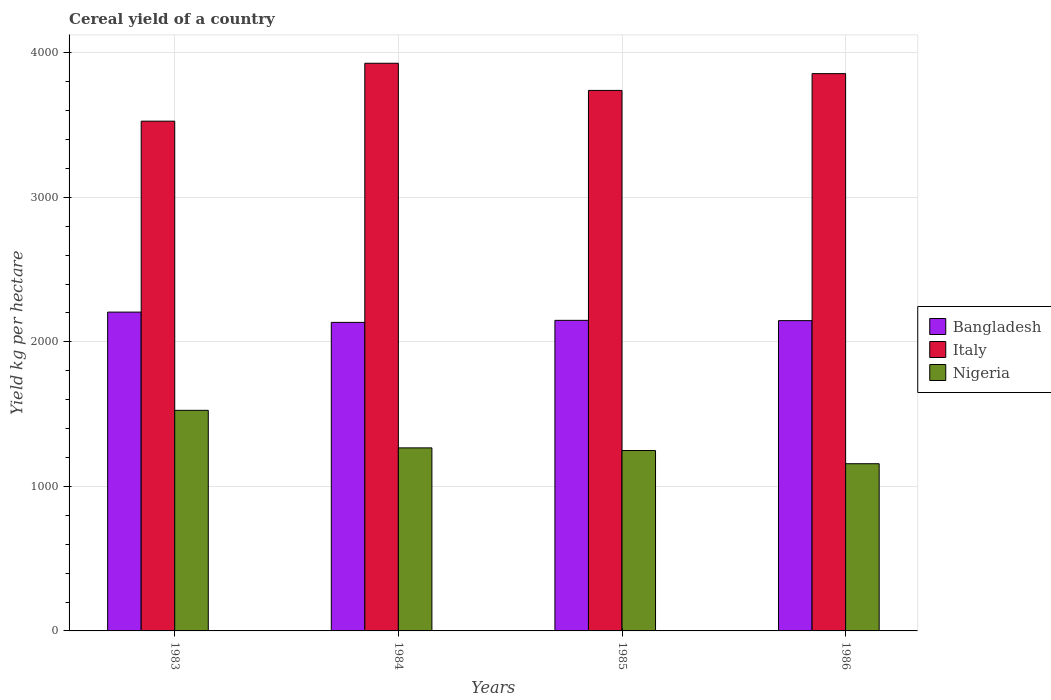How many groups of bars are there?
Give a very brief answer. 4. Are the number of bars per tick equal to the number of legend labels?
Your answer should be very brief. Yes. How many bars are there on the 4th tick from the left?
Offer a terse response. 3. What is the total cereal yield in Nigeria in 1983?
Offer a very short reply. 1526.02. Across all years, what is the maximum total cereal yield in Bangladesh?
Make the answer very short. 2205.6. Across all years, what is the minimum total cereal yield in Nigeria?
Your answer should be very brief. 1156.71. In which year was the total cereal yield in Bangladesh minimum?
Offer a very short reply. 1984. What is the total total cereal yield in Bangladesh in the graph?
Provide a succinct answer. 8635.34. What is the difference between the total cereal yield in Nigeria in 1983 and that in 1984?
Your answer should be very brief. 259.68. What is the difference between the total cereal yield in Bangladesh in 1986 and the total cereal yield in Nigeria in 1983?
Give a very brief answer. 620.63. What is the average total cereal yield in Bangladesh per year?
Your answer should be very brief. 2158.84. In the year 1984, what is the difference between the total cereal yield in Nigeria and total cereal yield in Bangladesh?
Ensure brevity in your answer.  -868.22. In how many years, is the total cereal yield in Italy greater than 2000 kg per hectare?
Make the answer very short. 4. What is the ratio of the total cereal yield in Bangladesh in 1983 to that in 1986?
Give a very brief answer. 1.03. Is the difference between the total cereal yield in Nigeria in 1985 and 1986 greater than the difference between the total cereal yield in Bangladesh in 1985 and 1986?
Keep it short and to the point. Yes. What is the difference between the highest and the second highest total cereal yield in Nigeria?
Keep it short and to the point. 259.68. What is the difference between the highest and the lowest total cereal yield in Bangladesh?
Provide a short and direct response. 71.04. In how many years, is the total cereal yield in Bangladesh greater than the average total cereal yield in Bangladesh taken over all years?
Make the answer very short. 1. What does the 2nd bar from the left in 1984 represents?
Provide a short and direct response. Italy. Are all the bars in the graph horizontal?
Give a very brief answer. No. How many years are there in the graph?
Offer a terse response. 4. What is the difference between two consecutive major ticks on the Y-axis?
Offer a terse response. 1000. Does the graph contain grids?
Offer a terse response. Yes. Where does the legend appear in the graph?
Your answer should be very brief. Center right. What is the title of the graph?
Give a very brief answer. Cereal yield of a country. What is the label or title of the X-axis?
Provide a short and direct response. Years. What is the label or title of the Y-axis?
Your answer should be very brief. Yield kg per hectare. What is the Yield kg per hectare in Bangladesh in 1983?
Offer a terse response. 2205.6. What is the Yield kg per hectare in Italy in 1983?
Keep it short and to the point. 3526.6. What is the Yield kg per hectare of Nigeria in 1983?
Ensure brevity in your answer.  1526.02. What is the Yield kg per hectare of Bangladesh in 1984?
Provide a short and direct response. 2134.56. What is the Yield kg per hectare of Italy in 1984?
Offer a terse response. 3927.2. What is the Yield kg per hectare in Nigeria in 1984?
Offer a terse response. 1266.34. What is the Yield kg per hectare in Bangladesh in 1985?
Provide a short and direct response. 2148.54. What is the Yield kg per hectare of Italy in 1985?
Your response must be concise. 3739.32. What is the Yield kg per hectare of Nigeria in 1985?
Make the answer very short. 1247.93. What is the Yield kg per hectare of Bangladesh in 1986?
Give a very brief answer. 2146.64. What is the Yield kg per hectare of Italy in 1986?
Offer a very short reply. 3855.44. What is the Yield kg per hectare in Nigeria in 1986?
Make the answer very short. 1156.71. Across all years, what is the maximum Yield kg per hectare of Bangladesh?
Keep it short and to the point. 2205.6. Across all years, what is the maximum Yield kg per hectare in Italy?
Your answer should be compact. 3927.2. Across all years, what is the maximum Yield kg per hectare of Nigeria?
Your response must be concise. 1526.02. Across all years, what is the minimum Yield kg per hectare of Bangladesh?
Provide a short and direct response. 2134.56. Across all years, what is the minimum Yield kg per hectare in Italy?
Offer a very short reply. 3526.6. Across all years, what is the minimum Yield kg per hectare in Nigeria?
Offer a very short reply. 1156.71. What is the total Yield kg per hectare in Bangladesh in the graph?
Provide a succinct answer. 8635.34. What is the total Yield kg per hectare of Italy in the graph?
Give a very brief answer. 1.50e+04. What is the total Yield kg per hectare of Nigeria in the graph?
Provide a succinct answer. 5196.99. What is the difference between the Yield kg per hectare in Bangladesh in 1983 and that in 1984?
Make the answer very short. 71.04. What is the difference between the Yield kg per hectare of Italy in 1983 and that in 1984?
Your response must be concise. -400.6. What is the difference between the Yield kg per hectare in Nigeria in 1983 and that in 1984?
Your answer should be very brief. 259.68. What is the difference between the Yield kg per hectare in Bangladesh in 1983 and that in 1985?
Provide a succinct answer. 57.06. What is the difference between the Yield kg per hectare of Italy in 1983 and that in 1985?
Offer a very short reply. -212.72. What is the difference between the Yield kg per hectare in Nigeria in 1983 and that in 1985?
Offer a very short reply. 278.09. What is the difference between the Yield kg per hectare of Bangladesh in 1983 and that in 1986?
Offer a terse response. 58.96. What is the difference between the Yield kg per hectare of Italy in 1983 and that in 1986?
Your answer should be compact. -328.84. What is the difference between the Yield kg per hectare in Nigeria in 1983 and that in 1986?
Offer a terse response. 369.3. What is the difference between the Yield kg per hectare in Bangladesh in 1984 and that in 1985?
Make the answer very short. -13.98. What is the difference between the Yield kg per hectare of Italy in 1984 and that in 1985?
Your answer should be very brief. 187.88. What is the difference between the Yield kg per hectare in Nigeria in 1984 and that in 1985?
Provide a succinct answer. 18.41. What is the difference between the Yield kg per hectare of Bangladesh in 1984 and that in 1986?
Your answer should be compact. -12.08. What is the difference between the Yield kg per hectare of Italy in 1984 and that in 1986?
Provide a succinct answer. 71.76. What is the difference between the Yield kg per hectare of Nigeria in 1984 and that in 1986?
Offer a very short reply. 109.62. What is the difference between the Yield kg per hectare of Bangladesh in 1985 and that in 1986?
Offer a terse response. 1.9. What is the difference between the Yield kg per hectare of Italy in 1985 and that in 1986?
Offer a very short reply. -116.12. What is the difference between the Yield kg per hectare of Nigeria in 1985 and that in 1986?
Your response must be concise. 91.22. What is the difference between the Yield kg per hectare of Bangladesh in 1983 and the Yield kg per hectare of Italy in 1984?
Make the answer very short. -1721.6. What is the difference between the Yield kg per hectare in Bangladesh in 1983 and the Yield kg per hectare in Nigeria in 1984?
Offer a very short reply. 939.26. What is the difference between the Yield kg per hectare of Italy in 1983 and the Yield kg per hectare of Nigeria in 1984?
Provide a short and direct response. 2260.26. What is the difference between the Yield kg per hectare in Bangladesh in 1983 and the Yield kg per hectare in Italy in 1985?
Offer a terse response. -1533.71. What is the difference between the Yield kg per hectare of Bangladesh in 1983 and the Yield kg per hectare of Nigeria in 1985?
Ensure brevity in your answer.  957.67. What is the difference between the Yield kg per hectare in Italy in 1983 and the Yield kg per hectare in Nigeria in 1985?
Provide a succinct answer. 2278.67. What is the difference between the Yield kg per hectare of Bangladesh in 1983 and the Yield kg per hectare of Italy in 1986?
Your answer should be very brief. -1649.84. What is the difference between the Yield kg per hectare of Bangladesh in 1983 and the Yield kg per hectare of Nigeria in 1986?
Make the answer very short. 1048.89. What is the difference between the Yield kg per hectare in Italy in 1983 and the Yield kg per hectare in Nigeria in 1986?
Provide a short and direct response. 2369.89. What is the difference between the Yield kg per hectare in Bangladesh in 1984 and the Yield kg per hectare in Italy in 1985?
Offer a very short reply. -1604.76. What is the difference between the Yield kg per hectare of Bangladesh in 1984 and the Yield kg per hectare of Nigeria in 1985?
Your answer should be very brief. 886.63. What is the difference between the Yield kg per hectare of Italy in 1984 and the Yield kg per hectare of Nigeria in 1985?
Offer a very short reply. 2679.27. What is the difference between the Yield kg per hectare in Bangladesh in 1984 and the Yield kg per hectare in Italy in 1986?
Offer a very short reply. -1720.88. What is the difference between the Yield kg per hectare in Bangladesh in 1984 and the Yield kg per hectare in Nigeria in 1986?
Offer a very short reply. 977.85. What is the difference between the Yield kg per hectare of Italy in 1984 and the Yield kg per hectare of Nigeria in 1986?
Offer a terse response. 2770.48. What is the difference between the Yield kg per hectare of Bangladesh in 1985 and the Yield kg per hectare of Italy in 1986?
Give a very brief answer. -1706.89. What is the difference between the Yield kg per hectare of Bangladesh in 1985 and the Yield kg per hectare of Nigeria in 1986?
Ensure brevity in your answer.  991.83. What is the difference between the Yield kg per hectare of Italy in 1985 and the Yield kg per hectare of Nigeria in 1986?
Your answer should be very brief. 2582.6. What is the average Yield kg per hectare in Bangladesh per year?
Keep it short and to the point. 2158.84. What is the average Yield kg per hectare of Italy per year?
Make the answer very short. 3762.14. What is the average Yield kg per hectare in Nigeria per year?
Give a very brief answer. 1299.25. In the year 1983, what is the difference between the Yield kg per hectare in Bangladesh and Yield kg per hectare in Italy?
Give a very brief answer. -1321. In the year 1983, what is the difference between the Yield kg per hectare of Bangladesh and Yield kg per hectare of Nigeria?
Ensure brevity in your answer.  679.58. In the year 1983, what is the difference between the Yield kg per hectare of Italy and Yield kg per hectare of Nigeria?
Provide a short and direct response. 2000.58. In the year 1984, what is the difference between the Yield kg per hectare of Bangladesh and Yield kg per hectare of Italy?
Provide a succinct answer. -1792.64. In the year 1984, what is the difference between the Yield kg per hectare in Bangladesh and Yield kg per hectare in Nigeria?
Your answer should be very brief. 868.22. In the year 1984, what is the difference between the Yield kg per hectare of Italy and Yield kg per hectare of Nigeria?
Make the answer very short. 2660.86. In the year 1985, what is the difference between the Yield kg per hectare in Bangladesh and Yield kg per hectare in Italy?
Make the answer very short. -1590.77. In the year 1985, what is the difference between the Yield kg per hectare of Bangladesh and Yield kg per hectare of Nigeria?
Give a very brief answer. 900.62. In the year 1985, what is the difference between the Yield kg per hectare of Italy and Yield kg per hectare of Nigeria?
Keep it short and to the point. 2491.39. In the year 1986, what is the difference between the Yield kg per hectare in Bangladesh and Yield kg per hectare in Italy?
Provide a succinct answer. -1708.8. In the year 1986, what is the difference between the Yield kg per hectare of Bangladesh and Yield kg per hectare of Nigeria?
Offer a very short reply. 989.93. In the year 1986, what is the difference between the Yield kg per hectare of Italy and Yield kg per hectare of Nigeria?
Give a very brief answer. 2698.73. What is the ratio of the Yield kg per hectare in Italy in 1983 to that in 1984?
Offer a terse response. 0.9. What is the ratio of the Yield kg per hectare of Nigeria in 1983 to that in 1984?
Your answer should be very brief. 1.21. What is the ratio of the Yield kg per hectare in Bangladesh in 1983 to that in 1985?
Ensure brevity in your answer.  1.03. What is the ratio of the Yield kg per hectare of Italy in 1983 to that in 1985?
Provide a succinct answer. 0.94. What is the ratio of the Yield kg per hectare of Nigeria in 1983 to that in 1985?
Offer a very short reply. 1.22. What is the ratio of the Yield kg per hectare of Bangladesh in 1983 to that in 1986?
Provide a succinct answer. 1.03. What is the ratio of the Yield kg per hectare of Italy in 1983 to that in 1986?
Your response must be concise. 0.91. What is the ratio of the Yield kg per hectare in Nigeria in 1983 to that in 1986?
Your answer should be compact. 1.32. What is the ratio of the Yield kg per hectare of Bangladesh in 1984 to that in 1985?
Make the answer very short. 0.99. What is the ratio of the Yield kg per hectare of Italy in 1984 to that in 1985?
Make the answer very short. 1.05. What is the ratio of the Yield kg per hectare in Nigeria in 1984 to that in 1985?
Provide a succinct answer. 1.01. What is the ratio of the Yield kg per hectare of Italy in 1984 to that in 1986?
Make the answer very short. 1.02. What is the ratio of the Yield kg per hectare of Nigeria in 1984 to that in 1986?
Keep it short and to the point. 1.09. What is the ratio of the Yield kg per hectare in Bangladesh in 1985 to that in 1986?
Provide a short and direct response. 1. What is the ratio of the Yield kg per hectare of Italy in 1985 to that in 1986?
Provide a short and direct response. 0.97. What is the ratio of the Yield kg per hectare in Nigeria in 1985 to that in 1986?
Provide a succinct answer. 1.08. What is the difference between the highest and the second highest Yield kg per hectare in Bangladesh?
Your answer should be very brief. 57.06. What is the difference between the highest and the second highest Yield kg per hectare of Italy?
Make the answer very short. 71.76. What is the difference between the highest and the second highest Yield kg per hectare of Nigeria?
Keep it short and to the point. 259.68. What is the difference between the highest and the lowest Yield kg per hectare in Bangladesh?
Ensure brevity in your answer.  71.04. What is the difference between the highest and the lowest Yield kg per hectare of Italy?
Give a very brief answer. 400.6. What is the difference between the highest and the lowest Yield kg per hectare of Nigeria?
Make the answer very short. 369.3. 